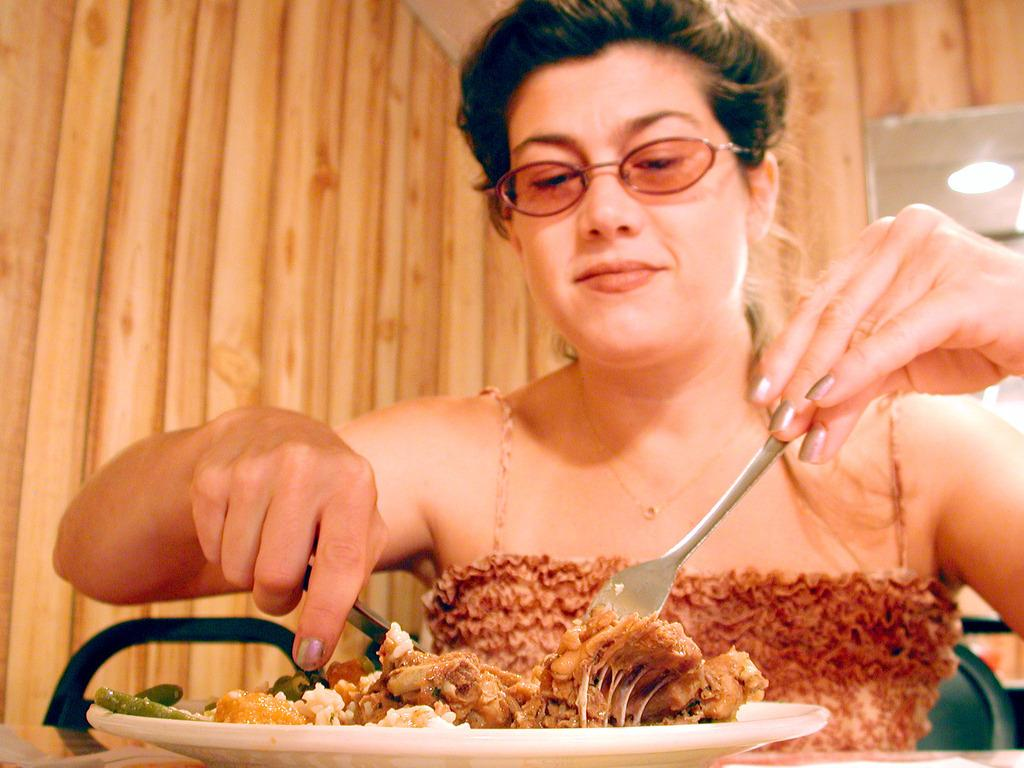What is the person in the image holding? The person in the image is holding spoons. What is on the plate that is visible in the image? There are food items on a plate in the image. Where is the plate located in the image? The plate is on a table in the image. What can be seen attached to the roof in the image? There is a light attached to the roof in the image. What is one of the structural elements in the image? There is a wall in the image. What type of needle is being used by the person in the image? There is no needle present in the image; the person is holding spoons. What is the reason for the gathering in the image? There is no indication of a gathering or party in the image; it simply shows a person holding spoons and food items on a plate. 